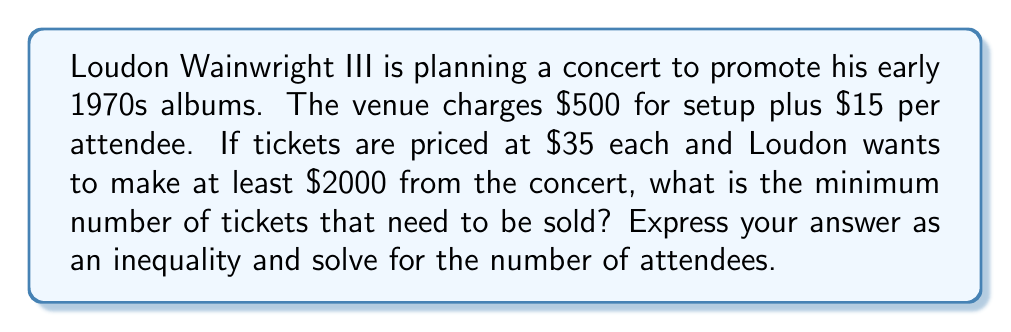Solve this math problem. Let's approach this step-by-step:

1) Let $x$ be the number of attendees.

2) Revenue from ticket sales: $35x$

3) Venue costs: $500 + 15x$

4) Loudon's profit: $35x - (500 + 15x) = 20x - 500$

5) We want this profit to be at least $2000:

   $20x - 500 \geq 2000$

6) Solve the inequality:
   
   $20x \geq 2500$
   
   $x \geq 125$

7) Since we can't have a fractional number of attendees, we need to round up to the nearest whole number.

Therefore, the minimum number of tickets that need to be sold is 125.
Answer: $x \geq 125$ 